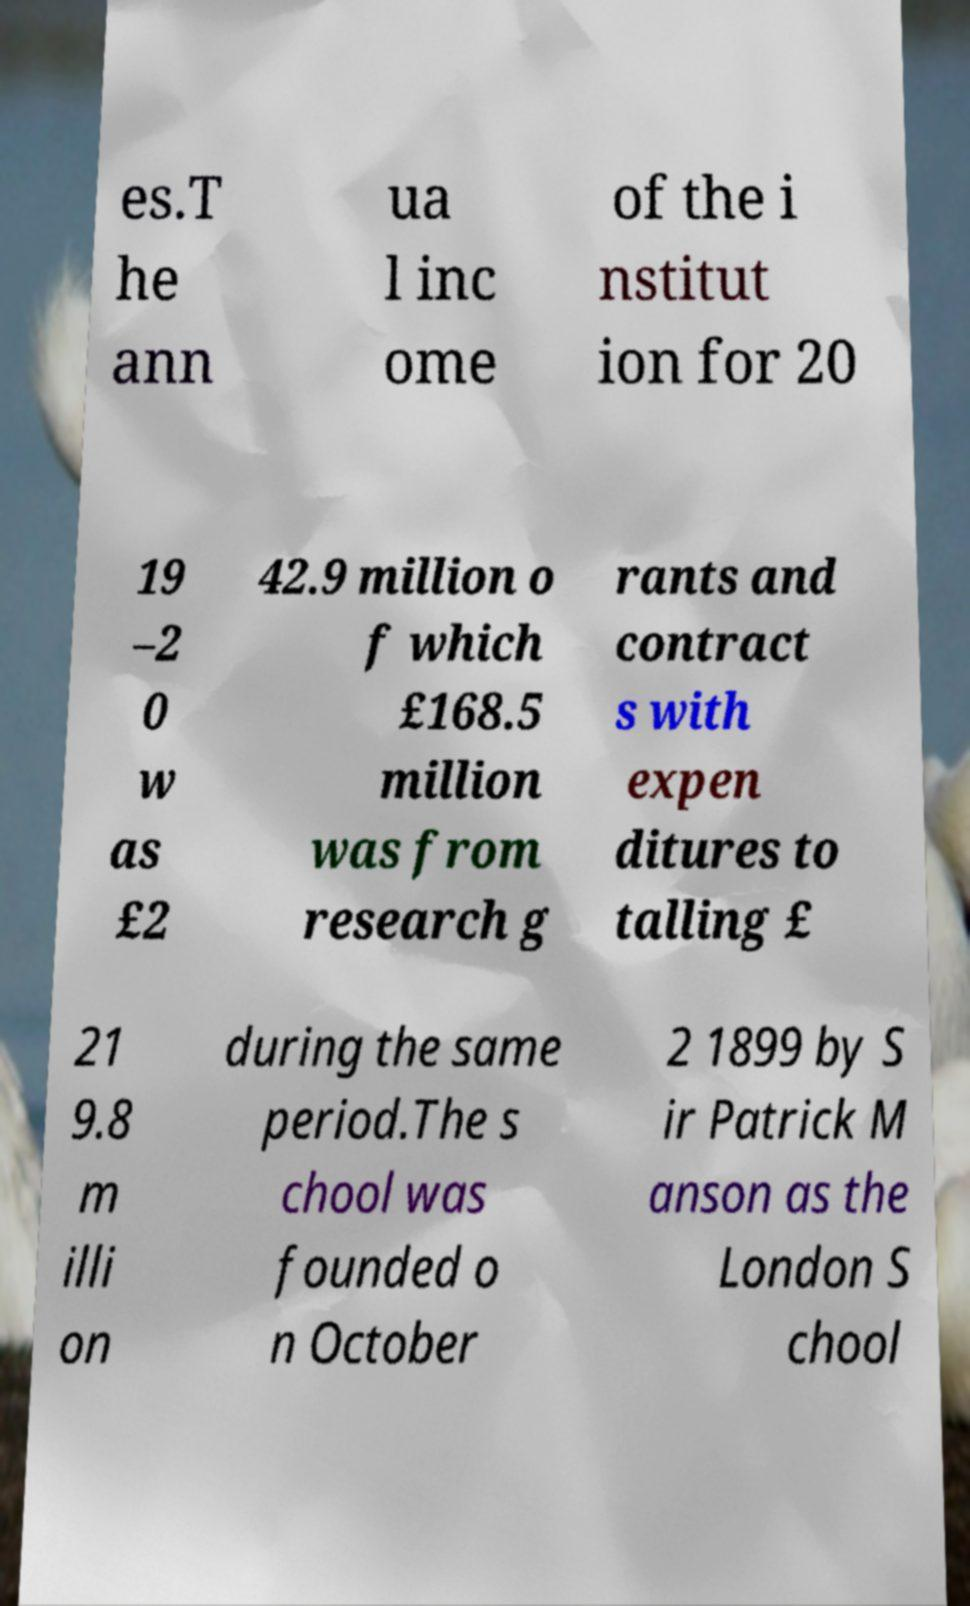Could you assist in decoding the text presented in this image and type it out clearly? es.T he ann ua l inc ome of the i nstitut ion for 20 19 –2 0 w as £2 42.9 million o f which £168.5 million was from research g rants and contract s with expen ditures to talling £ 21 9.8 m illi on during the same period.The s chool was founded o n October 2 1899 by S ir Patrick M anson as the London S chool 